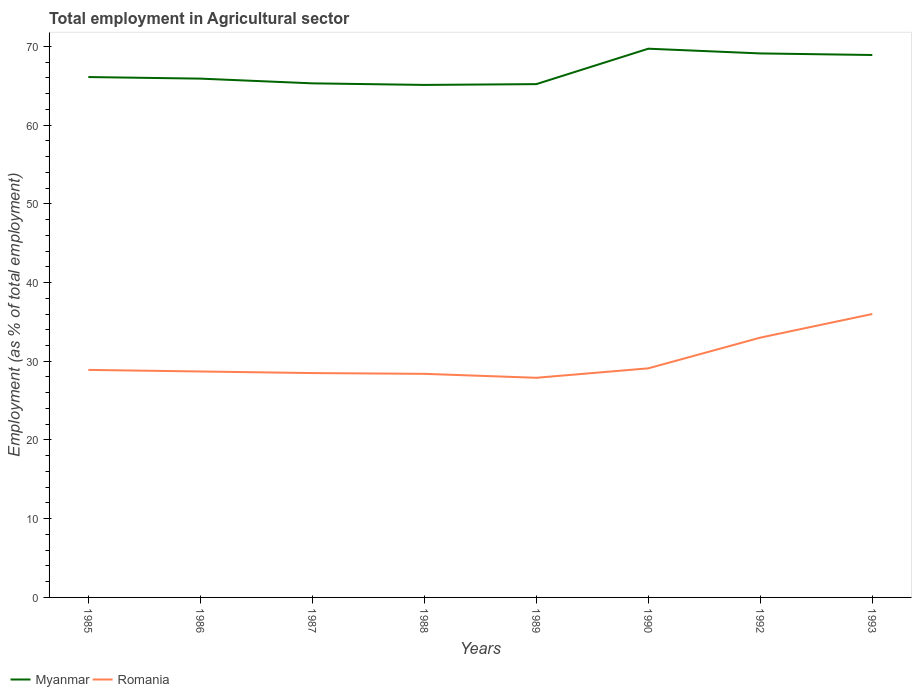Across all years, what is the maximum employment in agricultural sector in Romania?
Make the answer very short. 27.9. What is the total employment in agricultural sector in Myanmar in the graph?
Provide a short and direct response. -3.7. What is the difference between the highest and the second highest employment in agricultural sector in Romania?
Keep it short and to the point. 8.1. What is the difference between the highest and the lowest employment in agricultural sector in Myanmar?
Provide a succinct answer. 3. How many lines are there?
Make the answer very short. 2. How many years are there in the graph?
Your answer should be compact. 8. Does the graph contain any zero values?
Keep it short and to the point. No. Does the graph contain grids?
Offer a very short reply. No. How many legend labels are there?
Offer a very short reply. 2. How are the legend labels stacked?
Provide a succinct answer. Horizontal. What is the title of the graph?
Offer a terse response. Total employment in Agricultural sector. What is the label or title of the Y-axis?
Offer a terse response. Employment (as % of total employment). What is the Employment (as % of total employment) in Myanmar in 1985?
Give a very brief answer. 66.1. What is the Employment (as % of total employment) in Romania in 1985?
Provide a succinct answer. 28.9. What is the Employment (as % of total employment) of Myanmar in 1986?
Offer a very short reply. 65.9. What is the Employment (as % of total employment) in Romania in 1986?
Provide a short and direct response. 28.7. What is the Employment (as % of total employment) in Myanmar in 1987?
Offer a very short reply. 65.3. What is the Employment (as % of total employment) in Romania in 1987?
Your response must be concise. 28.5. What is the Employment (as % of total employment) of Myanmar in 1988?
Give a very brief answer. 65.1. What is the Employment (as % of total employment) of Romania in 1988?
Keep it short and to the point. 28.4. What is the Employment (as % of total employment) in Myanmar in 1989?
Keep it short and to the point. 65.2. What is the Employment (as % of total employment) of Romania in 1989?
Give a very brief answer. 27.9. What is the Employment (as % of total employment) of Myanmar in 1990?
Give a very brief answer. 69.7. What is the Employment (as % of total employment) of Romania in 1990?
Your answer should be compact. 29.1. What is the Employment (as % of total employment) of Myanmar in 1992?
Ensure brevity in your answer.  69.1. What is the Employment (as % of total employment) in Myanmar in 1993?
Offer a very short reply. 68.9. What is the Employment (as % of total employment) of Romania in 1993?
Ensure brevity in your answer.  36. Across all years, what is the maximum Employment (as % of total employment) in Myanmar?
Your response must be concise. 69.7. Across all years, what is the minimum Employment (as % of total employment) in Myanmar?
Offer a terse response. 65.1. Across all years, what is the minimum Employment (as % of total employment) in Romania?
Offer a terse response. 27.9. What is the total Employment (as % of total employment) of Myanmar in the graph?
Make the answer very short. 535.3. What is the total Employment (as % of total employment) in Romania in the graph?
Your answer should be compact. 240.5. What is the difference between the Employment (as % of total employment) of Myanmar in 1985 and that in 1986?
Give a very brief answer. 0.2. What is the difference between the Employment (as % of total employment) of Romania in 1985 and that in 1986?
Your response must be concise. 0.2. What is the difference between the Employment (as % of total employment) in Romania in 1985 and that in 1988?
Keep it short and to the point. 0.5. What is the difference between the Employment (as % of total employment) in Romania in 1985 and that in 1989?
Give a very brief answer. 1. What is the difference between the Employment (as % of total employment) of Romania in 1985 and that in 1990?
Your answer should be compact. -0.2. What is the difference between the Employment (as % of total employment) of Myanmar in 1985 and that in 1992?
Provide a short and direct response. -3. What is the difference between the Employment (as % of total employment) of Myanmar in 1985 and that in 1993?
Offer a very short reply. -2.8. What is the difference between the Employment (as % of total employment) in Myanmar in 1986 and that in 1987?
Your response must be concise. 0.6. What is the difference between the Employment (as % of total employment) of Romania in 1986 and that in 1987?
Offer a very short reply. 0.2. What is the difference between the Employment (as % of total employment) of Romania in 1986 and that in 1988?
Make the answer very short. 0.3. What is the difference between the Employment (as % of total employment) in Romania in 1986 and that in 1989?
Make the answer very short. 0.8. What is the difference between the Employment (as % of total employment) of Myanmar in 1986 and that in 1992?
Make the answer very short. -3.2. What is the difference between the Employment (as % of total employment) of Romania in 1986 and that in 1993?
Give a very brief answer. -7.3. What is the difference between the Employment (as % of total employment) of Romania in 1987 and that in 1992?
Give a very brief answer. -4.5. What is the difference between the Employment (as % of total employment) in Myanmar in 1987 and that in 1993?
Provide a short and direct response. -3.6. What is the difference between the Employment (as % of total employment) of Romania in 1987 and that in 1993?
Keep it short and to the point. -7.5. What is the difference between the Employment (as % of total employment) in Myanmar in 1988 and that in 1989?
Offer a terse response. -0.1. What is the difference between the Employment (as % of total employment) of Romania in 1988 and that in 1989?
Keep it short and to the point. 0.5. What is the difference between the Employment (as % of total employment) of Myanmar in 1988 and that in 1992?
Give a very brief answer. -4. What is the difference between the Employment (as % of total employment) of Myanmar in 1988 and that in 1993?
Your answer should be compact. -3.8. What is the difference between the Employment (as % of total employment) of Myanmar in 1989 and that in 1990?
Provide a short and direct response. -4.5. What is the difference between the Employment (as % of total employment) of Romania in 1990 and that in 1992?
Make the answer very short. -3.9. What is the difference between the Employment (as % of total employment) in Romania in 1992 and that in 1993?
Your response must be concise. -3. What is the difference between the Employment (as % of total employment) in Myanmar in 1985 and the Employment (as % of total employment) in Romania in 1986?
Make the answer very short. 37.4. What is the difference between the Employment (as % of total employment) of Myanmar in 1985 and the Employment (as % of total employment) of Romania in 1987?
Make the answer very short. 37.6. What is the difference between the Employment (as % of total employment) of Myanmar in 1985 and the Employment (as % of total employment) of Romania in 1988?
Provide a succinct answer. 37.7. What is the difference between the Employment (as % of total employment) in Myanmar in 1985 and the Employment (as % of total employment) in Romania in 1989?
Your response must be concise. 38.2. What is the difference between the Employment (as % of total employment) in Myanmar in 1985 and the Employment (as % of total employment) in Romania in 1992?
Ensure brevity in your answer.  33.1. What is the difference between the Employment (as % of total employment) of Myanmar in 1985 and the Employment (as % of total employment) of Romania in 1993?
Ensure brevity in your answer.  30.1. What is the difference between the Employment (as % of total employment) in Myanmar in 1986 and the Employment (as % of total employment) in Romania in 1987?
Make the answer very short. 37.4. What is the difference between the Employment (as % of total employment) of Myanmar in 1986 and the Employment (as % of total employment) of Romania in 1988?
Your answer should be very brief. 37.5. What is the difference between the Employment (as % of total employment) of Myanmar in 1986 and the Employment (as % of total employment) of Romania in 1990?
Give a very brief answer. 36.8. What is the difference between the Employment (as % of total employment) in Myanmar in 1986 and the Employment (as % of total employment) in Romania in 1992?
Your answer should be compact. 32.9. What is the difference between the Employment (as % of total employment) in Myanmar in 1986 and the Employment (as % of total employment) in Romania in 1993?
Your answer should be compact. 29.9. What is the difference between the Employment (as % of total employment) in Myanmar in 1987 and the Employment (as % of total employment) in Romania in 1988?
Provide a succinct answer. 36.9. What is the difference between the Employment (as % of total employment) in Myanmar in 1987 and the Employment (as % of total employment) in Romania in 1989?
Give a very brief answer. 37.4. What is the difference between the Employment (as % of total employment) of Myanmar in 1987 and the Employment (as % of total employment) of Romania in 1990?
Your response must be concise. 36.2. What is the difference between the Employment (as % of total employment) in Myanmar in 1987 and the Employment (as % of total employment) in Romania in 1992?
Ensure brevity in your answer.  32.3. What is the difference between the Employment (as % of total employment) of Myanmar in 1987 and the Employment (as % of total employment) of Romania in 1993?
Ensure brevity in your answer.  29.3. What is the difference between the Employment (as % of total employment) in Myanmar in 1988 and the Employment (as % of total employment) in Romania in 1989?
Offer a terse response. 37.2. What is the difference between the Employment (as % of total employment) in Myanmar in 1988 and the Employment (as % of total employment) in Romania in 1992?
Keep it short and to the point. 32.1. What is the difference between the Employment (as % of total employment) of Myanmar in 1988 and the Employment (as % of total employment) of Romania in 1993?
Make the answer very short. 29.1. What is the difference between the Employment (as % of total employment) of Myanmar in 1989 and the Employment (as % of total employment) of Romania in 1990?
Give a very brief answer. 36.1. What is the difference between the Employment (as % of total employment) in Myanmar in 1989 and the Employment (as % of total employment) in Romania in 1992?
Ensure brevity in your answer.  32.2. What is the difference between the Employment (as % of total employment) of Myanmar in 1989 and the Employment (as % of total employment) of Romania in 1993?
Give a very brief answer. 29.2. What is the difference between the Employment (as % of total employment) of Myanmar in 1990 and the Employment (as % of total employment) of Romania in 1992?
Your answer should be very brief. 36.7. What is the difference between the Employment (as % of total employment) of Myanmar in 1990 and the Employment (as % of total employment) of Romania in 1993?
Your answer should be compact. 33.7. What is the difference between the Employment (as % of total employment) in Myanmar in 1992 and the Employment (as % of total employment) in Romania in 1993?
Offer a very short reply. 33.1. What is the average Employment (as % of total employment) of Myanmar per year?
Your response must be concise. 66.91. What is the average Employment (as % of total employment) of Romania per year?
Provide a succinct answer. 30.06. In the year 1985, what is the difference between the Employment (as % of total employment) in Myanmar and Employment (as % of total employment) in Romania?
Offer a very short reply. 37.2. In the year 1986, what is the difference between the Employment (as % of total employment) in Myanmar and Employment (as % of total employment) in Romania?
Your answer should be very brief. 37.2. In the year 1987, what is the difference between the Employment (as % of total employment) in Myanmar and Employment (as % of total employment) in Romania?
Offer a very short reply. 36.8. In the year 1988, what is the difference between the Employment (as % of total employment) in Myanmar and Employment (as % of total employment) in Romania?
Provide a short and direct response. 36.7. In the year 1989, what is the difference between the Employment (as % of total employment) in Myanmar and Employment (as % of total employment) in Romania?
Ensure brevity in your answer.  37.3. In the year 1990, what is the difference between the Employment (as % of total employment) in Myanmar and Employment (as % of total employment) in Romania?
Offer a terse response. 40.6. In the year 1992, what is the difference between the Employment (as % of total employment) of Myanmar and Employment (as % of total employment) of Romania?
Provide a short and direct response. 36.1. In the year 1993, what is the difference between the Employment (as % of total employment) in Myanmar and Employment (as % of total employment) in Romania?
Ensure brevity in your answer.  32.9. What is the ratio of the Employment (as % of total employment) in Myanmar in 1985 to that in 1987?
Your answer should be very brief. 1.01. What is the ratio of the Employment (as % of total employment) of Romania in 1985 to that in 1987?
Your response must be concise. 1.01. What is the ratio of the Employment (as % of total employment) in Myanmar in 1985 to that in 1988?
Ensure brevity in your answer.  1.02. What is the ratio of the Employment (as % of total employment) of Romania in 1985 to that in 1988?
Your response must be concise. 1.02. What is the ratio of the Employment (as % of total employment) of Myanmar in 1985 to that in 1989?
Your response must be concise. 1.01. What is the ratio of the Employment (as % of total employment) of Romania in 1985 to that in 1989?
Provide a short and direct response. 1.04. What is the ratio of the Employment (as % of total employment) in Myanmar in 1985 to that in 1990?
Ensure brevity in your answer.  0.95. What is the ratio of the Employment (as % of total employment) in Myanmar in 1985 to that in 1992?
Give a very brief answer. 0.96. What is the ratio of the Employment (as % of total employment) of Romania in 1985 to that in 1992?
Offer a terse response. 0.88. What is the ratio of the Employment (as % of total employment) in Myanmar in 1985 to that in 1993?
Provide a short and direct response. 0.96. What is the ratio of the Employment (as % of total employment) in Romania in 1985 to that in 1993?
Provide a short and direct response. 0.8. What is the ratio of the Employment (as % of total employment) in Myanmar in 1986 to that in 1987?
Make the answer very short. 1.01. What is the ratio of the Employment (as % of total employment) in Myanmar in 1986 to that in 1988?
Keep it short and to the point. 1.01. What is the ratio of the Employment (as % of total employment) of Romania in 1986 to that in 1988?
Offer a terse response. 1.01. What is the ratio of the Employment (as % of total employment) in Myanmar in 1986 to that in 1989?
Give a very brief answer. 1.01. What is the ratio of the Employment (as % of total employment) in Romania in 1986 to that in 1989?
Offer a very short reply. 1.03. What is the ratio of the Employment (as % of total employment) in Myanmar in 1986 to that in 1990?
Your response must be concise. 0.95. What is the ratio of the Employment (as % of total employment) in Romania in 1986 to that in 1990?
Make the answer very short. 0.99. What is the ratio of the Employment (as % of total employment) of Myanmar in 1986 to that in 1992?
Keep it short and to the point. 0.95. What is the ratio of the Employment (as % of total employment) of Romania in 1986 to that in 1992?
Ensure brevity in your answer.  0.87. What is the ratio of the Employment (as % of total employment) in Myanmar in 1986 to that in 1993?
Provide a succinct answer. 0.96. What is the ratio of the Employment (as % of total employment) of Romania in 1986 to that in 1993?
Ensure brevity in your answer.  0.8. What is the ratio of the Employment (as % of total employment) in Myanmar in 1987 to that in 1988?
Offer a terse response. 1. What is the ratio of the Employment (as % of total employment) of Romania in 1987 to that in 1988?
Your answer should be compact. 1. What is the ratio of the Employment (as % of total employment) in Romania in 1987 to that in 1989?
Make the answer very short. 1.02. What is the ratio of the Employment (as % of total employment) of Myanmar in 1987 to that in 1990?
Give a very brief answer. 0.94. What is the ratio of the Employment (as % of total employment) of Romania in 1987 to that in 1990?
Give a very brief answer. 0.98. What is the ratio of the Employment (as % of total employment) in Myanmar in 1987 to that in 1992?
Give a very brief answer. 0.94. What is the ratio of the Employment (as % of total employment) in Romania in 1987 to that in 1992?
Your answer should be very brief. 0.86. What is the ratio of the Employment (as % of total employment) in Myanmar in 1987 to that in 1993?
Ensure brevity in your answer.  0.95. What is the ratio of the Employment (as % of total employment) of Romania in 1987 to that in 1993?
Keep it short and to the point. 0.79. What is the ratio of the Employment (as % of total employment) in Myanmar in 1988 to that in 1989?
Your response must be concise. 1. What is the ratio of the Employment (as % of total employment) of Romania in 1988 to that in 1989?
Your answer should be very brief. 1.02. What is the ratio of the Employment (as % of total employment) of Myanmar in 1988 to that in 1990?
Your response must be concise. 0.93. What is the ratio of the Employment (as % of total employment) in Romania in 1988 to that in 1990?
Offer a terse response. 0.98. What is the ratio of the Employment (as % of total employment) of Myanmar in 1988 to that in 1992?
Your response must be concise. 0.94. What is the ratio of the Employment (as % of total employment) of Romania in 1988 to that in 1992?
Your response must be concise. 0.86. What is the ratio of the Employment (as % of total employment) of Myanmar in 1988 to that in 1993?
Your answer should be very brief. 0.94. What is the ratio of the Employment (as % of total employment) of Romania in 1988 to that in 1993?
Keep it short and to the point. 0.79. What is the ratio of the Employment (as % of total employment) in Myanmar in 1989 to that in 1990?
Keep it short and to the point. 0.94. What is the ratio of the Employment (as % of total employment) of Romania in 1989 to that in 1990?
Keep it short and to the point. 0.96. What is the ratio of the Employment (as % of total employment) of Myanmar in 1989 to that in 1992?
Provide a succinct answer. 0.94. What is the ratio of the Employment (as % of total employment) of Romania in 1989 to that in 1992?
Offer a very short reply. 0.85. What is the ratio of the Employment (as % of total employment) of Myanmar in 1989 to that in 1993?
Give a very brief answer. 0.95. What is the ratio of the Employment (as % of total employment) of Romania in 1989 to that in 1993?
Ensure brevity in your answer.  0.78. What is the ratio of the Employment (as % of total employment) of Myanmar in 1990 to that in 1992?
Your answer should be compact. 1.01. What is the ratio of the Employment (as % of total employment) in Romania in 1990 to that in 1992?
Keep it short and to the point. 0.88. What is the ratio of the Employment (as % of total employment) of Myanmar in 1990 to that in 1993?
Provide a succinct answer. 1.01. What is the ratio of the Employment (as % of total employment) in Romania in 1990 to that in 1993?
Offer a very short reply. 0.81. What is the ratio of the Employment (as % of total employment) of Myanmar in 1992 to that in 1993?
Offer a terse response. 1. What is the ratio of the Employment (as % of total employment) in Romania in 1992 to that in 1993?
Offer a very short reply. 0.92. What is the difference between the highest and the second highest Employment (as % of total employment) in Myanmar?
Provide a succinct answer. 0.6. What is the difference between the highest and the lowest Employment (as % of total employment) of Myanmar?
Make the answer very short. 4.6. What is the difference between the highest and the lowest Employment (as % of total employment) of Romania?
Offer a terse response. 8.1. 